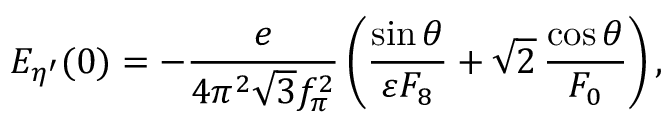<formula> <loc_0><loc_0><loc_500><loc_500>E _ { \eta ^ { \prime } } ( 0 ) = - \frac { e } { 4 \pi ^ { 2 } \sqrt { 3 } f _ { \pi } ^ { 2 } } \left ( \frac { \sin \theta } { \varepsilon F _ { 8 } } + \sqrt { 2 } \, \frac { \cos \theta } { F _ { 0 } } \right ) ,</formula> 